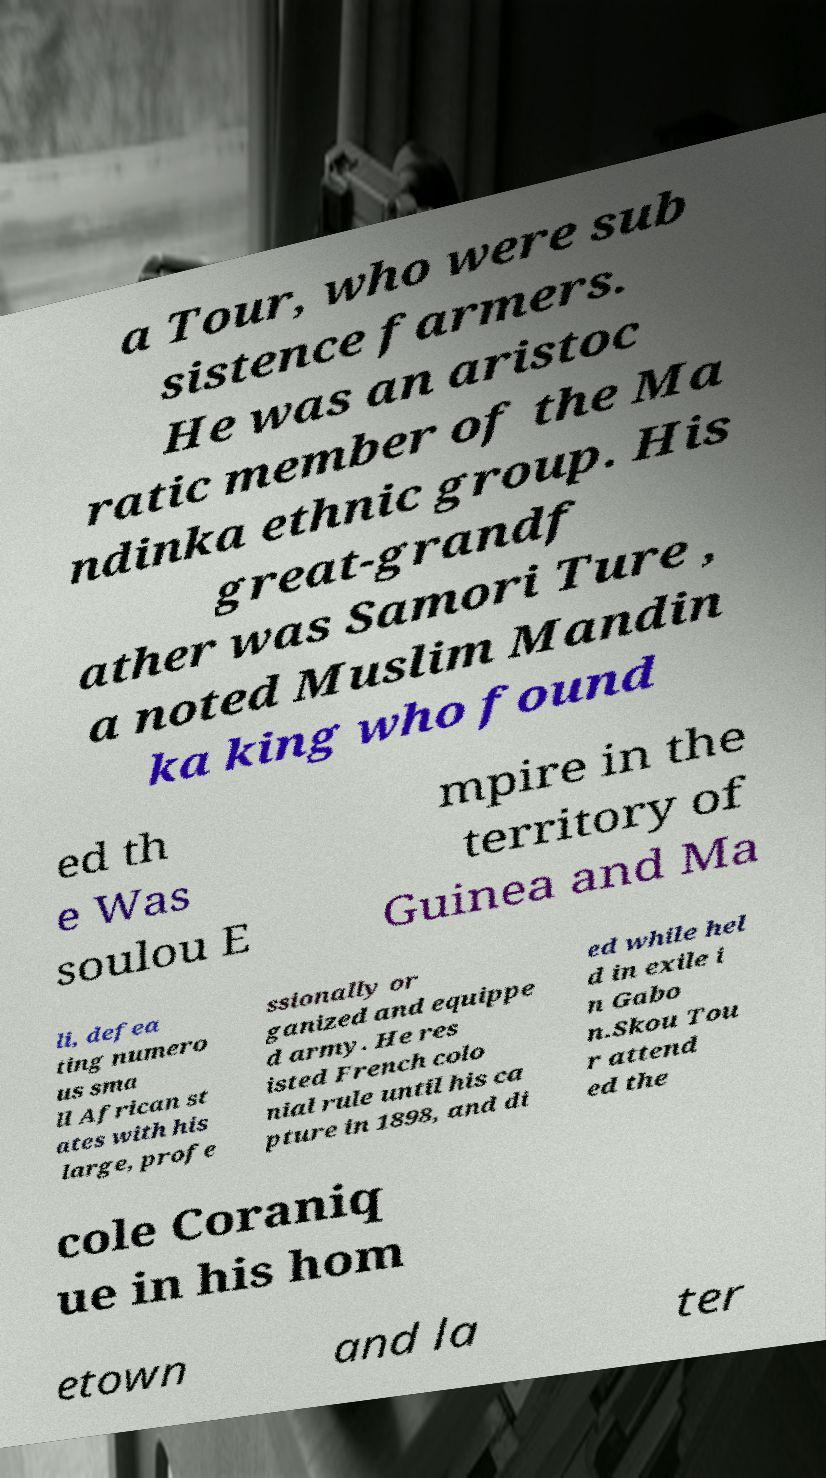There's text embedded in this image that I need extracted. Can you transcribe it verbatim? a Tour, who were sub sistence farmers. He was an aristoc ratic member of the Ma ndinka ethnic group. His great-grandf ather was Samori Ture , a noted Muslim Mandin ka king who found ed th e Was soulou E mpire in the territory of Guinea and Ma li, defea ting numero us sma ll African st ates with his large, profe ssionally or ganized and equippe d army. He res isted French colo nial rule until his ca pture in 1898, and di ed while hel d in exile i n Gabo n.Skou Tou r attend ed the cole Coraniq ue in his hom etown and la ter 